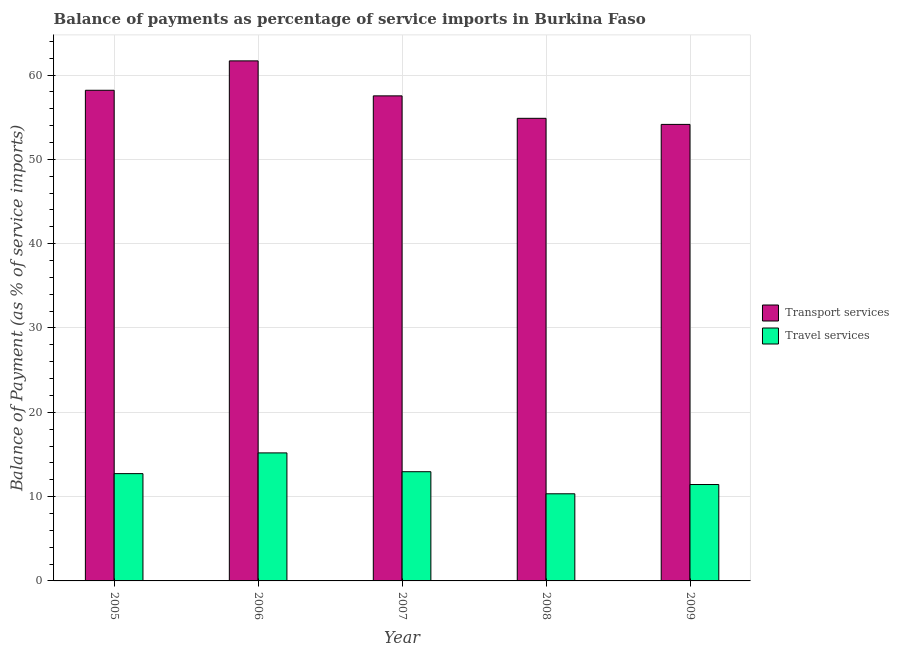How many groups of bars are there?
Give a very brief answer. 5. Are the number of bars per tick equal to the number of legend labels?
Give a very brief answer. Yes. Are the number of bars on each tick of the X-axis equal?
Your response must be concise. Yes. How many bars are there on the 5th tick from the left?
Offer a very short reply. 2. What is the label of the 1st group of bars from the left?
Give a very brief answer. 2005. What is the balance of payments of travel services in 2007?
Ensure brevity in your answer.  12.95. Across all years, what is the maximum balance of payments of transport services?
Your response must be concise. 61.68. Across all years, what is the minimum balance of payments of travel services?
Your answer should be compact. 10.33. In which year was the balance of payments of transport services minimum?
Your response must be concise. 2009. What is the total balance of payments of transport services in the graph?
Keep it short and to the point. 286.42. What is the difference between the balance of payments of transport services in 2006 and that in 2008?
Give a very brief answer. 6.81. What is the difference between the balance of payments of transport services in 2008 and the balance of payments of travel services in 2007?
Your answer should be very brief. -2.66. What is the average balance of payments of transport services per year?
Provide a succinct answer. 57.28. In how many years, is the balance of payments of transport services greater than 50 %?
Make the answer very short. 5. What is the ratio of the balance of payments of travel services in 2006 to that in 2008?
Your answer should be compact. 1.47. Is the balance of payments of transport services in 2007 less than that in 2009?
Make the answer very short. No. What is the difference between the highest and the second highest balance of payments of travel services?
Your response must be concise. 2.23. What is the difference between the highest and the lowest balance of payments of transport services?
Ensure brevity in your answer.  7.53. What does the 1st bar from the left in 2007 represents?
Give a very brief answer. Transport services. What does the 1st bar from the right in 2007 represents?
Give a very brief answer. Travel services. Are all the bars in the graph horizontal?
Make the answer very short. No. How many years are there in the graph?
Ensure brevity in your answer.  5. Does the graph contain any zero values?
Your response must be concise. No. Does the graph contain grids?
Ensure brevity in your answer.  Yes. Where does the legend appear in the graph?
Give a very brief answer. Center right. How are the legend labels stacked?
Make the answer very short. Vertical. What is the title of the graph?
Offer a terse response. Balance of payments as percentage of service imports in Burkina Faso. Does "Short-term debt" appear as one of the legend labels in the graph?
Give a very brief answer. No. What is the label or title of the Y-axis?
Your response must be concise. Balance of Payment (as % of service imports). What is the Balance of Payment (as % of service imports) of Transport services in 2005?
Your answer should be compact. 58.19. What is the Balance of Payment (as % of service imports) in Travel services in 2005?
Give a very brief answer. 12.73. What is the Balance of Payment (as % of service imports) in Transport services in 2006?
Your response must be concise. 61.68. What is the Balance of Payment (as % of service imports) of Travel services in 2006?
Keep it short and to the point. 15.18. What is the Balance of Payment (as % of service imports) in Transport services in 2007?
Offer a very short reply. 57.53. What is the Balance of Payment (as % of service imports) of Travel services in 2007?
Offer a very short reply. 12.95. What is the Balance of Payment (as % of service imports) of Transport services in 2008?
Provide a short and direct response. 54.87. What is the Balance of Payment (as % of service imports) of Travel services in 2008?
Offer a terse response. 10.33. What is the Balance of Payment (as % of service imports) in Transport services in 2009?
Make the answer very short. 54.15. What is the Balance of Payment (as % of service imports) in Travel services in 2009?
Offer a terse response. 11.43. Across all years, what is the maximum Balance of Payment (as % of service imports) in Transport services?
Provide a short and direct response. 61.68. Across all years, what is the maximum Balance of Payment (as % of service imports) in Travel services?
Make the answer very short. 15.18. Across all years, what is the minimum Balance of Payment (as % of service imports) in Transport services?
Your answer should be very brief. 54.15. Across all years, what is the minimum Balance of Payment (as % of service imports) of Travel services?
Make the answer very short. 10.33. What is the total Balance of Payment (as % of service imports) of Transport services in the graph?
Give a very brief answer. 286.42. What is the total Balance of Payment (as % of service imports) in Travel services in the graph?
Your response must be concise. 62.63. What is the difference between the Balance of Payment (as % of service imports) of Transport services in 2005 and that in 2006?
Ensure brevity in your answer.  -3.49. What is the difference between the Balance of Payment (as % of service imports) in Travel services in 2005 and that in 2006?
Your answer should be very brief. -2.46. What is the difference between the Balance of Payment (as % of service imports) of Transport services in 2005 and that in 2007?
Ensure brevity in your answer.  0.66. What is the difference between the Balance of Payment (as % of service imports) in Travel services in 2005 and that in 2007?
Keep it short and to the point. -0.23. What is the difference between the Balance of Payment (as % of service imports) of Transport services in 2005 and that in 2008?
Your answer should be compact. 3.33. What is the difference between the Balance of Payment (as % of service imports) in Travel services in 2005 and that in 2008?
Keep it short and to the point. 2.39. What is the difference between the Balance of Payment (as % of service imports) of Transport services in 2005 and that in 2009?
Your response must be concise. 4.05. What is the difference between the Balance of Payment (as % of service imports) in Travel services in 2005 and that in 2009?
Provide a short and direct response. 1.29. What is the difference between the Balance of Payment (as % of service imports) of Transport services in 2006 and that in 2007?
Your answer should be compact. 4.15. What is the difference between the Balance of Payment (as % of service imports) of Travel services in 2006 and that in 2007?
Your answer should be compact. 2.23. What is the difference between the Balance of Payment (as % of service imports) in Transport services in 2006 and that in 2008?
Keep it short and to the point. 6.81. What is the difference between the Balance of Payment (as % of service imports) in Travel services in 2006 and that in 2008?
Your answer should be very brief. 4.85. What is the difference between the Balance of Payment (as % of service imports) of Transport services in 2006 and that in 2009?
Your response must be concise. 7.53. What is the difference between the Balance of Payment (as % of service imports) of Travel services in 2006 and that in 2009?
Offer a very short reply. 3.75. What is the difference between the Balance of Payment (as % of service imports) of Transport services in 2007 and that in 2008?
Ensure brevity in your answer.  2.66. What is the difference between the Balance of Payment (as % of service imports) of Travel services in 2007 and that in 2008?
Your answer should be compact. 2.62. What is the difference between the Balance of Payment (as % of service imports) in Transport services in 2007 and that in 2009?
Make the answer very short. 3.38. What is the difference between the Balance of Payment (as % of service imports) in Travel services in 2007 and that in 2009?
Make the answer very short. 1.52. What is the difference between the Balance of Payment (as % of service imports) in Transport services in 2008 and that in 2009?
Your answer should be compact. 0.72. What is the difference between the Balance of Payment (as % of service imports) in Travel services in 2008 and that in 2009?
Keep it short and to the point. -1.1. What is the difference between the Balance of Payment (as % of service imports) of Transport services in 2005 and the Balance of Payment (as % of service imports) of Travel services in 2006?
Keep it short and to the point. 43.01. What is the difference between the Balance of Payment (as % of service imports) in Transport services in 2005 and the Balance of Payment (as % of service imports) in Travel services in 2007?
Provide a succinct answer. 45.24. What is the difference between the Balance of Payment (as % of service imports) of Transport services in 2005 and the Balance of Payment (as % of service imports) of Travel services in 2008?
Ensure brevity in your answer.  47.86. What is the difference between the Balance of Payment (as % of service imports) of Transport services in 2005 and the Balance of Payment (as % of service imports) of Travel services in 2009?
Ensure brevity in your answer.  46.76. What is the difference between the Balance of Payment (as % of service imports) of Transport services in 2006 and the Balance of Payment (as % of service imports) of Travel services in 2007?
Your answer should be compact. 48.73. What is the difference between the Balance of Payment (as % of service imports) of Transport services in 2006 and the Balance of Payment (as % of service imports) of Travel services in 2008?
Your answer should be very brief. 51.35. What is the difference between the Balance of Payment (as % of service imports) of Transport services in 2006 and the Balance of Payment (as % of service imports) of Travel services in 2009?
Offer a terse response. 50.25. What is the difference between the Balance of Payment (as % of service imports) in Transport services in 2007 and the Balance of Payment (as % of service imports) in Travel services in 2008?
Keep it short and to the point. 47.2. What is the difference between the Balance of Payment (as % of service imports) in Transport services in 2007 and the Balance of Payment (as % of service imports) in Travel services in 2009?
Make the answer very short. 46.1. What is the difference between the Balance of Payment (as % of service imports) in Transport services in 2008 and the Balance of Payment (as % of service imports) in Travel services in 2009?
Keep it short and to the point. 43.43. What is the average Balance of Payment (as % of service imports) in Transport services per year?
Provide a succinct answer. 57.28. What is the average Balance of Payment (as % of service imports) of Travel services per year?
Give a very brief answer. 12.53. In the year 2005, what is the difference between the Balance of Payment (as % of service imports) of Transport services and Balance of Payment (as % of service imports) of Travel services?
Your answer should be very brief. 45.47. In the year 2006, what is the difference between the Balance of Payment (as % of service imports) of Transport services and Balance of Payment (as % of service imports) of Travel services?
Give a very brief answer. 46.5. In the year 2007, what is the difference between the Balance of Payment (as % of service imports) of Transport services and Balance of Payment (as % of service imports) of Travel services?
Keep it short and to the point. 44.58. In the year 2008, what is the difference between the Balance of Payment (as % of service imports) of Transport services and Balance of Payment (as % of service imports) of Travel services?
Keep it short and to the point. 44.53. In the year 2009, what is the difference between the Balance of Payment (as % of service imports) of Transport services and Balance of Payment (as % of service imports) of Travel services?
Provide a short and direct response. 42.71. What is the ratio of the Balance of Payment (as % of service imports) in Transport services in 2005 to that in 2006?
Provide a short and direct response. 0.94. What is the ratio of the Balance of Payment (as % of service imports) of Travel services in 2005 to that in 2006?
Give a very brief answer. 0.84. What is the ratio of the Balance of Payment (as % of service imports) in Transport services in 2005 to that in 2007?
Provide a succinct answer. 1.01. What is the ratio of the Balance of Payment (as % of service imports) in Travel services in 2005 to that in 2007?
Offer a very short reply. 0.98. What is the ratio of the Balance of Payment (as % of service imports) in Transport services in 2005 to that in 2008?
Ensure brevity in your answer.  1.06. What is the ratio of the Balance of Payment (as % of service imports) of Travel services in 2005 to that in 2008?
Provide a short and direct response. 1.23. What is the ratio of the Balance of Payment (as % of service imports) in Transport services in 2005 to that in 2009?
Offer a very short reply. 1.07. What is the ratio of the Balance of Payment (as % of service imports) in Travel services in 2005 to that in 2009?
Provide a succinct answer. 1.11. What is the ratio of the Balance of Payment (as % of service imports) in Transport services in 2006 to that in 2007?
Provide a succinct answer. 1.07. What is the ratio of the Balance of Payment (as % of service imports) in Travel services in 2006 to that in 2007?
Your response must be concise. 1.17. What is the ratio of the Balance of Payment (as % of service imports) of Transport services in 2006 to that in 2008?
Provide a short and direct response. 1.12. What is the ratio of the Balance of Payment (as % of service imports) in Travel services in 2006 to that in 2008?
Offer a terse response. 1.47. What is the ratio of the Balance of Payment (as % of service imports) in Transport services in 2006 to that in 2009?
Your answer should be very brief. 1.14. What is the ratio of the Balance of Payment (as % of service imports) in Travel services in 2006 to that in 2009?
Give a very brief answer. 1.33. What is the ratio of the Balance of Payment (as % of service imports) of Transport services in 2007 to that in 2008?
Make the answer very short. 1.05. What is the ratio of the Balance of Payment (as % of service imports) in Travel services in 2007 to that in 2008?
Your answer should be very brief. 1.25. What is the ratio of the Balance of Payment (as % of service imports) in Transport services in 2007 to that in 2009?
Your answer should be compact. 1.06. What is the ratio of the Balance of Payment (as % of service imports) in Travel services in 2007 to that in 2009?
Provide a succinct answer. 1.13. What is the ratio of the Balance of Payment (as % of service imports) of Transport services in 2008 to that in 2009?
Give a very brief answer. 1.01. What is the ratio of the Balance of Payment (as % of service imports) of Travel services in 2008 to that in 2009?
Offer a very short reply. 0.9. What is the difference between the highest and the second highest Balance of Payment (as % of service imports) in Transport services?
Make the answer very short. 3.49. What is the difference between the highest and the second highest Balance of Payment (as % of service imports) in Travel services?
Give a very brief answer. 2.23. What is the difference between the highest and the lowest Balance of Payment (as % of service imports) of Transport services?
Offer a terse response. 7.53. What is the difference between the highest and the lowest Balance of Payment (as % of service imports) in Travel services?
Your answer should be compact. 4.85. 